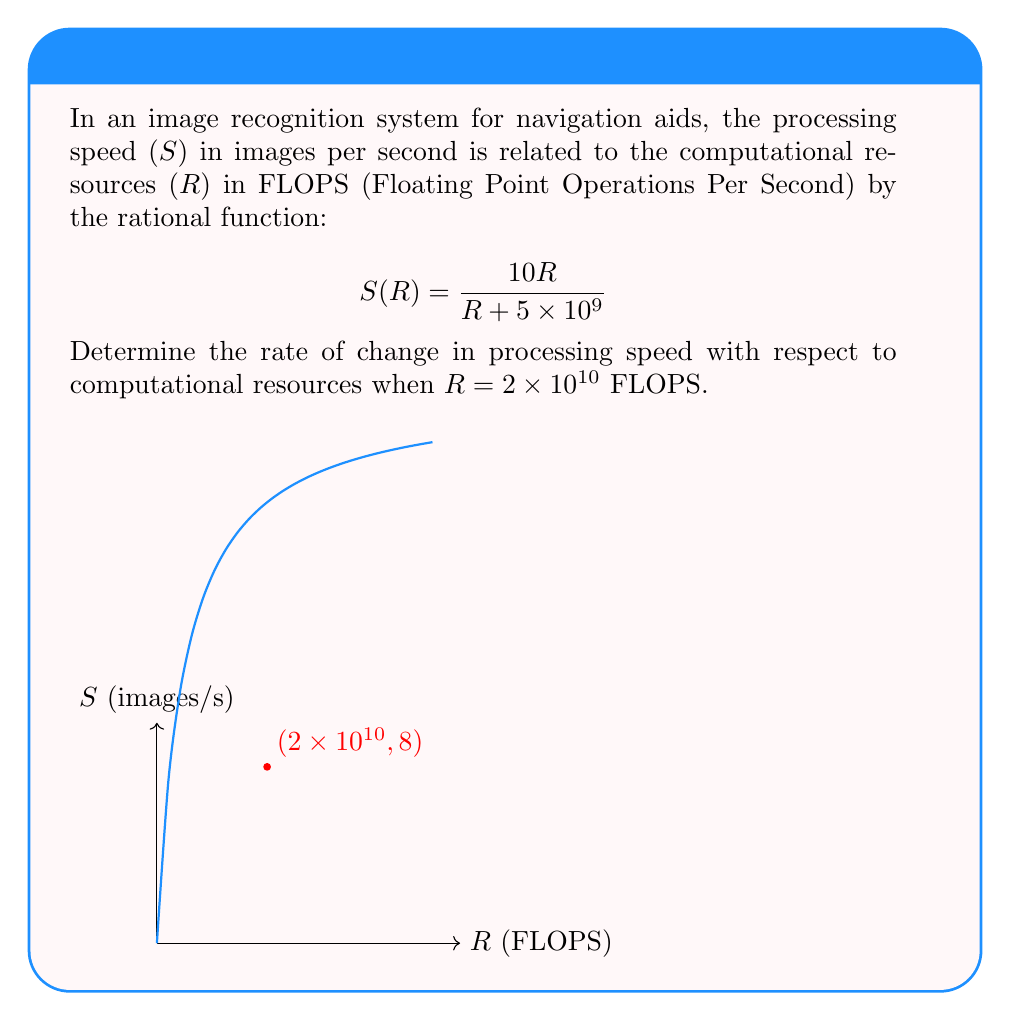Provide a solution to this math problem. To find the rate of change in processing speed with respect to computational resources, we need to differentiate $S(R)$ with respect to R and then evaluate it at R = $2 \times 10^{10}$ FLOPS.

Step 1: Differentiate $S(R)$ using the quotient rule.
$$ \frac{d}{dR}S(R) = \frac{d}{dR}\left(\frac{10R}{R + 5 \times 10^9}\right) $$
$$ = \frac{10(R + 5 \times 10^9) - 10R \cdot 1}{(R + 5 \times 10^9)^2} $$
$$ = \frac{10(5 \times 10^9)}{(R + 5 \times 10^9)^2} $$
$$ = \frac{5 \times 10^{10}}{(R + 5 \times 10^9)^2} $$

Step 2: Evaluate the derivative at R = $2 \times 10^{10}$ FLOPS.
$$ \left.\frac{dS}{dR}\right|_{R=2 \times 10^{10}} = \frac{5 \times 10^{10}}{(2 \times 10^{10} + 5 \times 10^9)^2} $$
$$ = \frac{5 \times 10^{10}}{(2.5 \times 10^{10})^2} $$
$$ = \frac{5 \times 10^{10}}{6.25 \times 10^{20}} $$
$$ = \frac{5}{6.25 \times 10^{10}} = \frac{1}{1.25 \times 10^{10}} = 8 \times 10^{-11} $$

Therefore, the rate of change in processing speed with respect to computational resources when R = $2 \times 10^{10}$ FLOPS is $8 \times 10^{-11}$ images per second per FLOPS.
Answer: $8 \times 10^{-11}$ images/s/FLOPS 